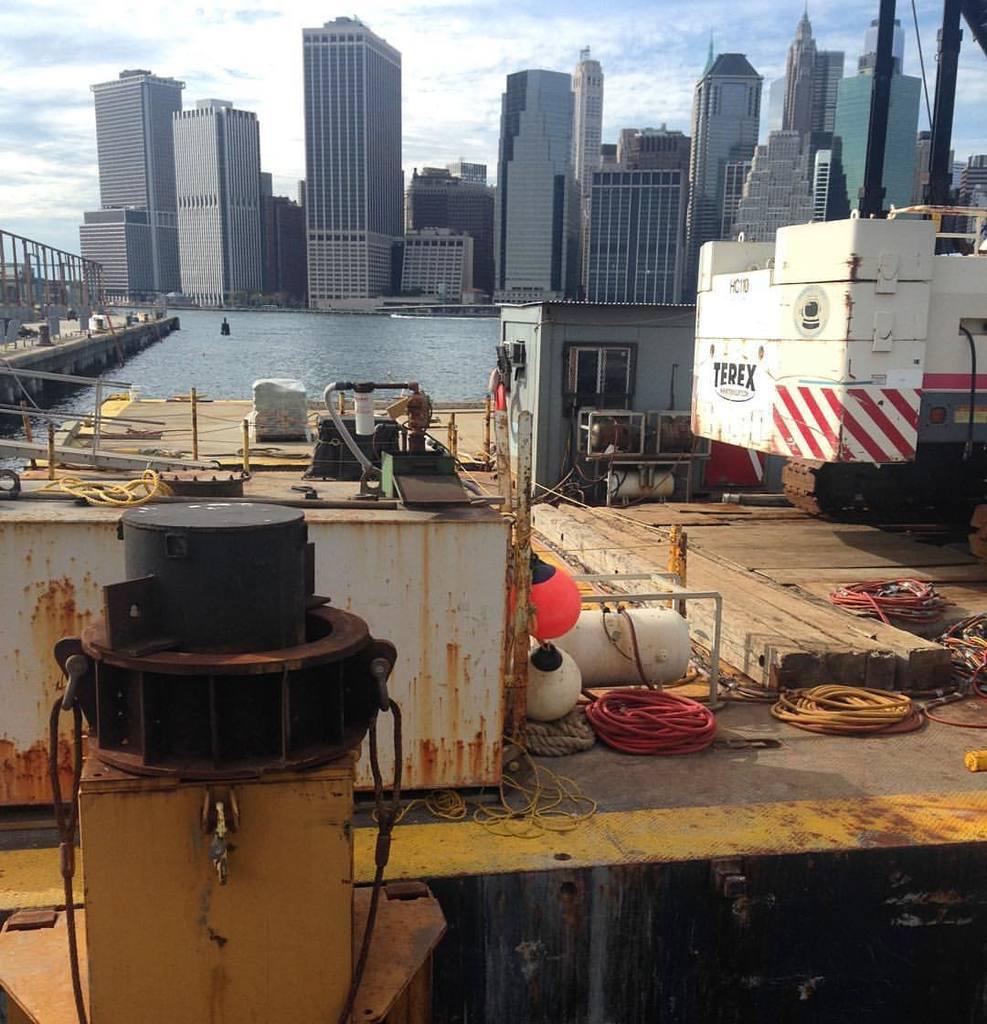Please provide a concise description of this image. In this image we can see many skyscrapers. There is a cloudy sky at the top most of the image. There is a sea in the center of the image and a bridge at the left most of the image. 